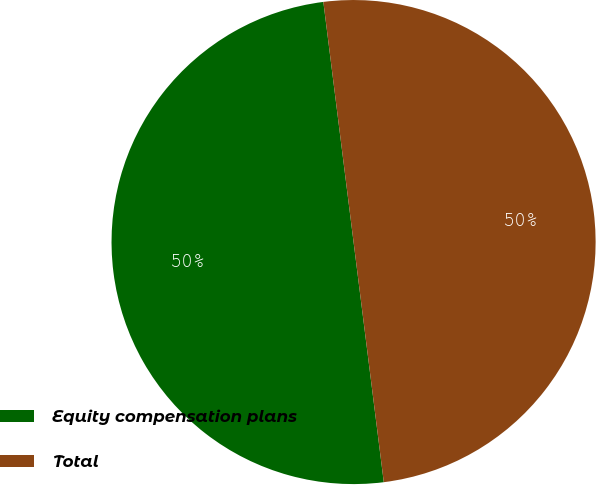Convert chart. <chart><loc_0><loc_0><loc_500><loc_500><pie_chart><fcel>Equity compensation plans<fcel>Total<nl><fcel>50.0%<fcel>50.0%<nl></chart> 